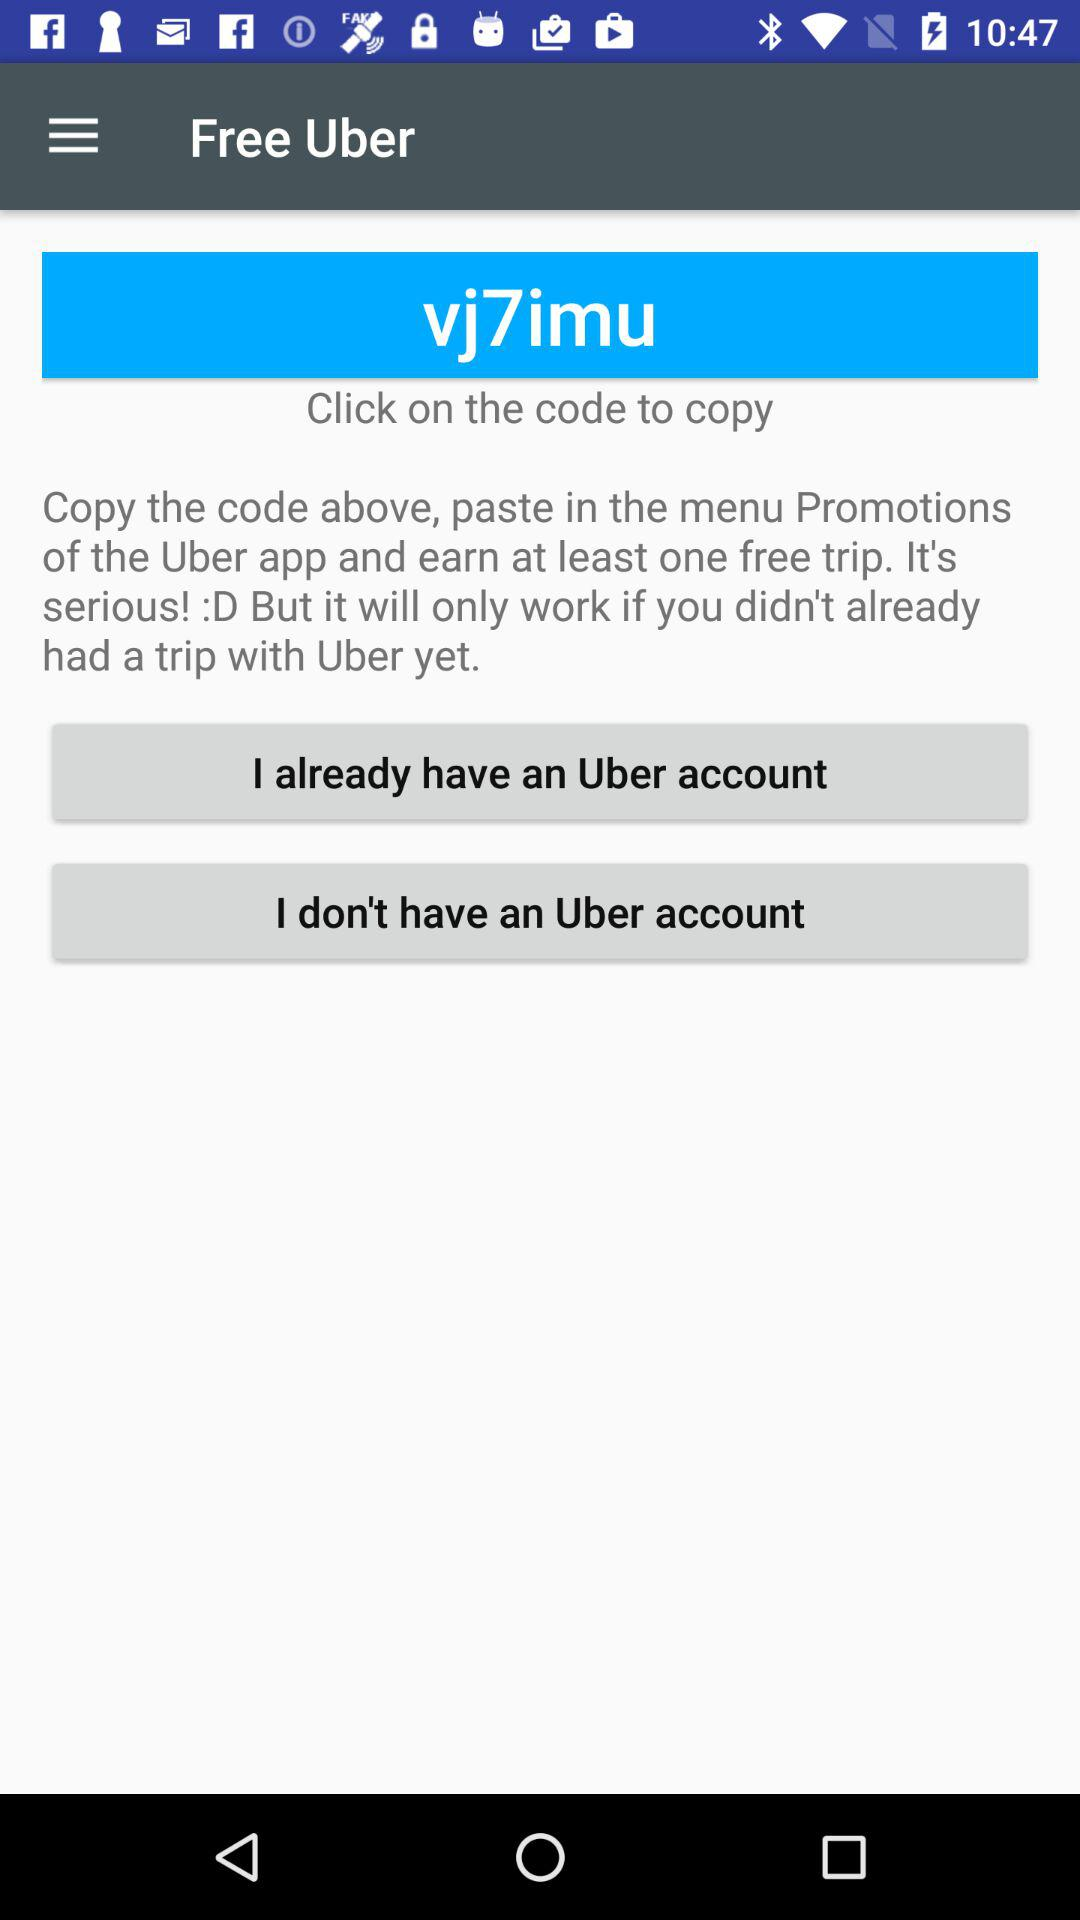What's the code? The code is "vj7imu". 